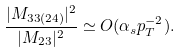Convert formula to latex. <formula><loc_0><loc_0><loc_500><loc_500>\frac { | M _ { 3 3 ( 2 4 ) } | ^ { 2 } } { | M _ { 2 3 } | ^ { 2 } } \simeq O ( \alpha _ { s } p _ { T } ^ { - 2 } ) .</formula> 